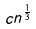Convert formula to latex. <formula><loc_0><loc_0><loc_500><loc_500>c n ^ { \frac { 1 } { 3 } }</formula> 